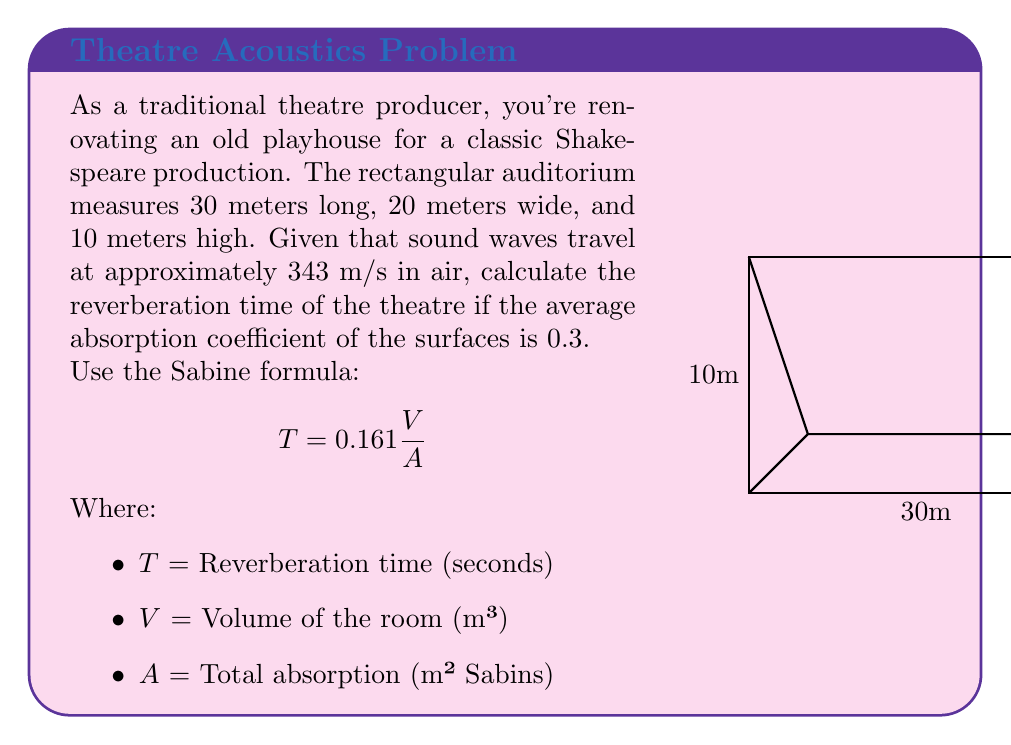Solve this math problem. Let's solve this step-by-step:

1) First, calculate the volume of the auditorium:
   $$V = length \times width \times height = 30 \times 20 \times 10 = 6000 \text{ m}^3$$

2) Next, calculate the total surface area:
   $$S_{total} = 2(length \times width + length \times height + width \times height)$$
   $$S_{total} = 2(30 \times 20 + 30 \times 10 + 20 \times 10) = 2600 \text{ m}^2$$

3) Calculate the total absorption:
   $$A = \alpha \times S_{total}$$
   Where $\alpha$ is the average absorption coefficient (0.3)
   $$A = 0.3 \times 2600 = 780 \text{ m}^2 \text{ Sabins}$$

4) Now we can apply the Sabine formula:
   $$T = 0.161 \frac{V}{A} = 0.161 \frac{6000}{780}$$

5) Simplify:
   $$T = 0.161 \times \frac{600}{78} = 1.24 \text{ seconds}$$

Therefore, the reverberation time of the theatre is approximately 1.24 seconds.
Answer: 1.24 seconds 